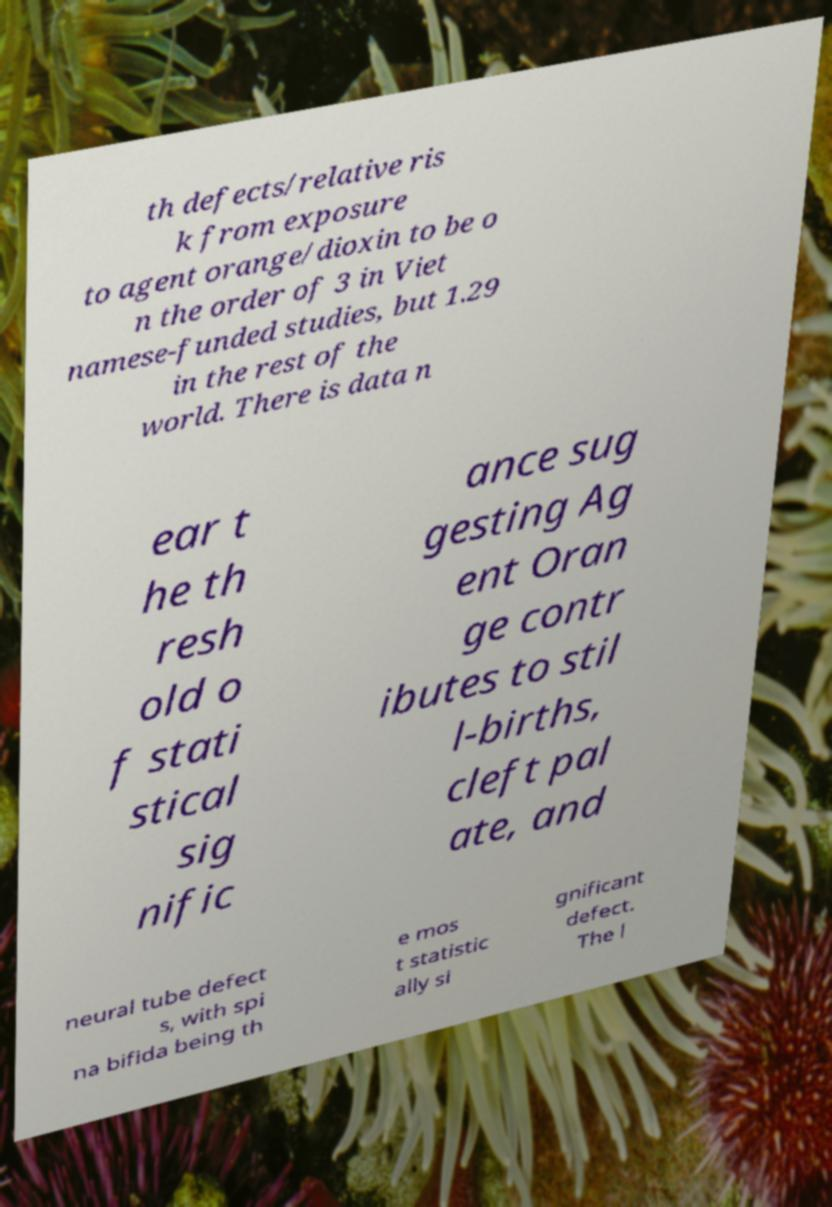For documentation purposes, I need the text within this image transcribed. Could you provide that? th defects/relative ris k from exposure to agent orange/dioxin to be o n the order of 3 in Viet namese-funded studies, but 1.29 in the rest of the world. There is data n ear t he th resh old o f stati stical sig nific ance sug gesting Ag ent Oran ge contr ibutes to stil l-births, cleft pal ate, and neural tube defect s, with spi na bifida being th e mos t statistic ally si gnificant defect. The l 